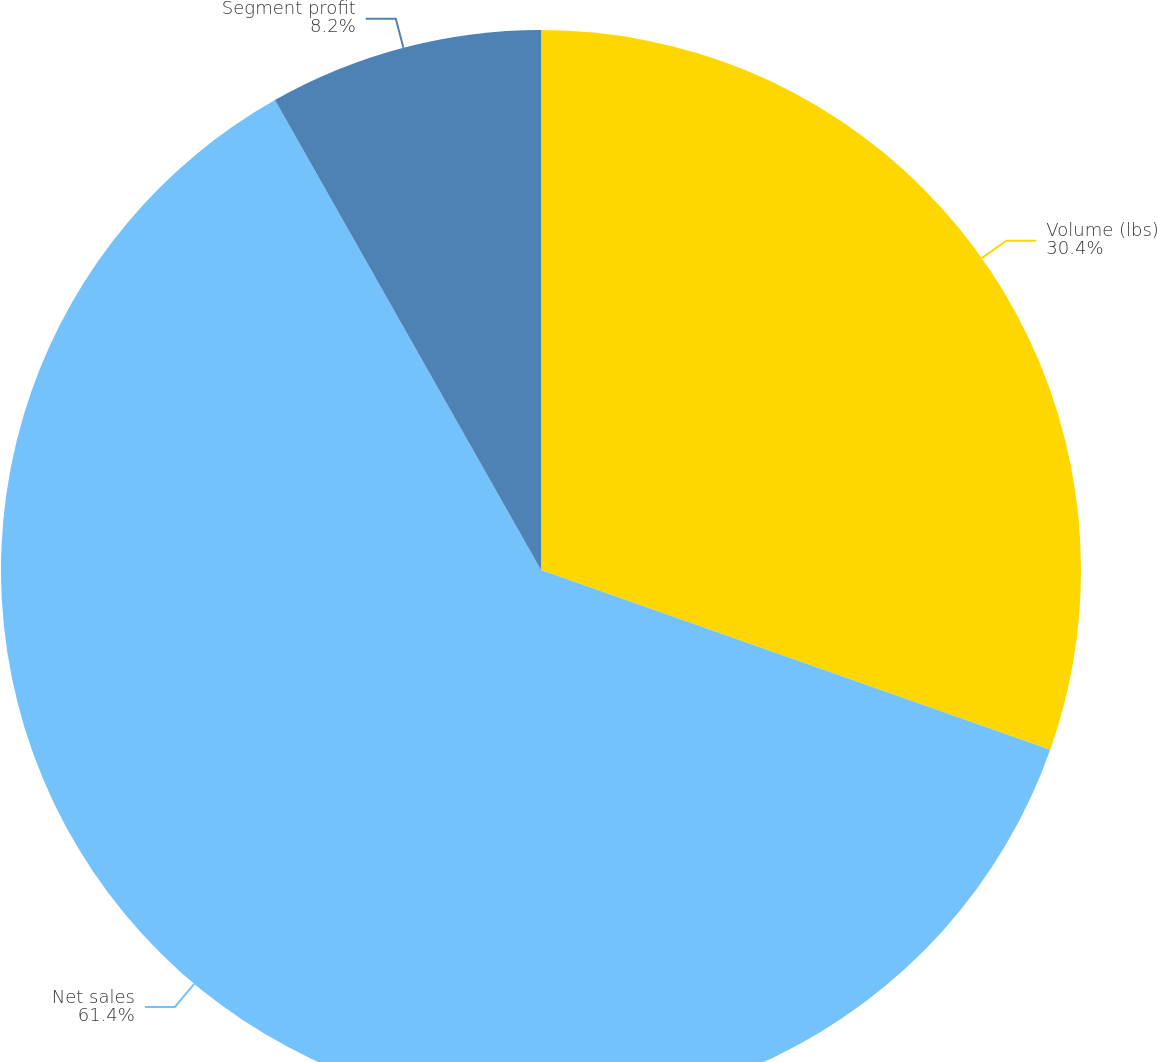Convert chart. <chart><loc_0><loc_0><loc_500><loc_500><pie_chart><fcel>Volume (lbs)<fcel>Net sales<fcel>Segment profit<nl><fcel>30.4%<fcel>61.4%<fcel>8.2%<nl></chart> 